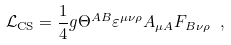<formula> <loc_0><loc_0><loc_500><loc_500>\mathcal { L } _ { \text {CS} } = \frac { 1 } { 4 } g \Theta ^ { A B } \varepsilon ^ { \mu \nu \rho } A _ { \mu A } F _ { B \nu \rho } \ ,</formula> 